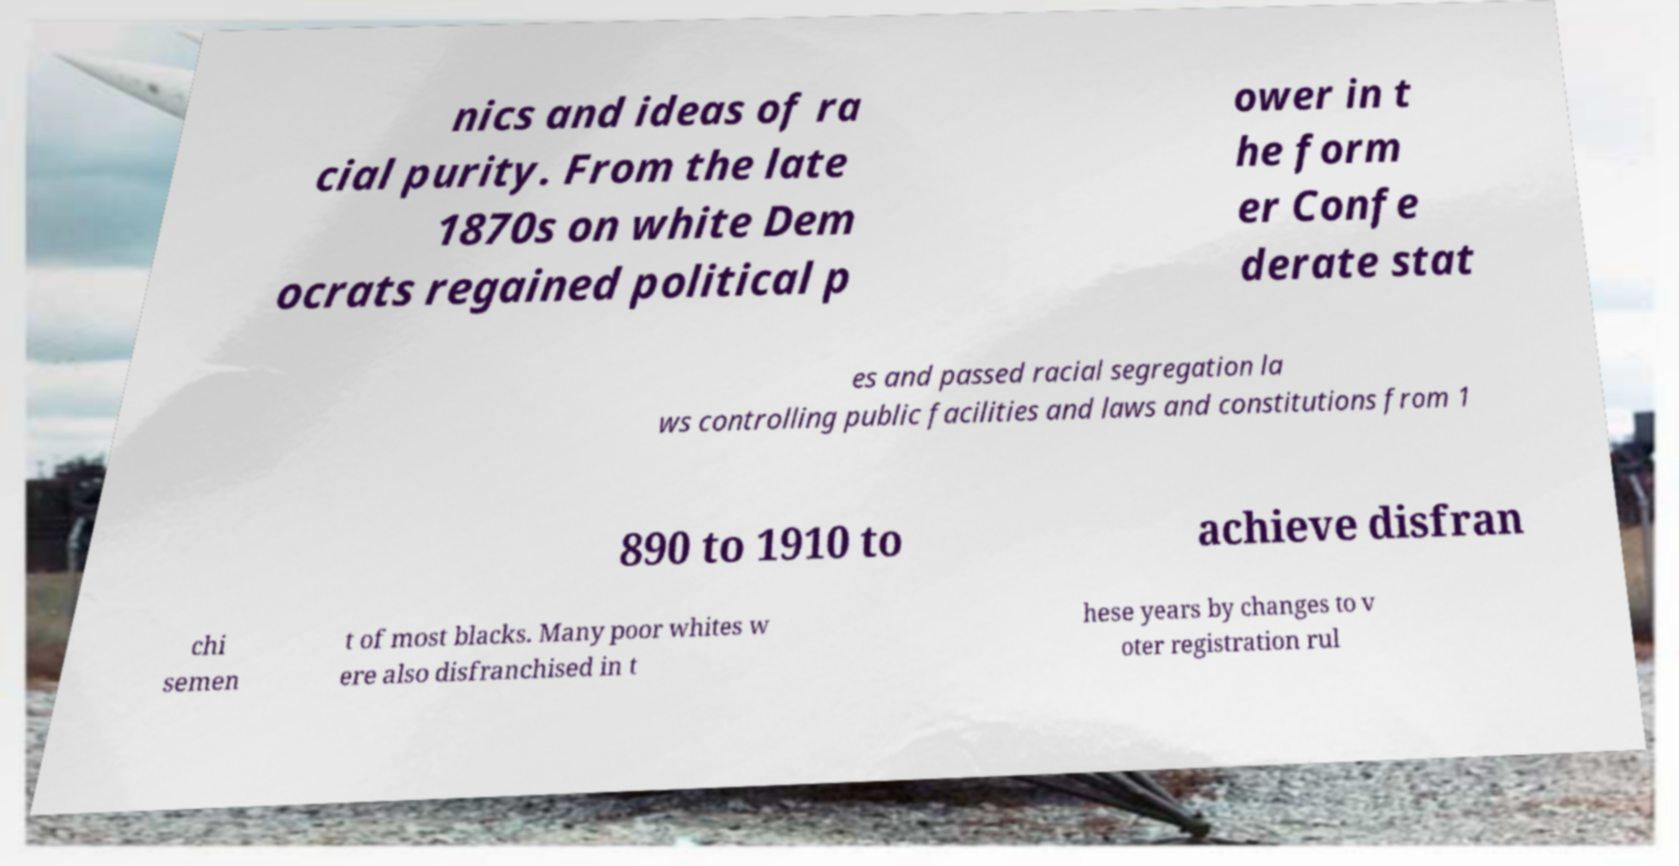What messages or text are displayed in this image? I need them in a readable, typed format. nics and ideas of ra cial purity. From the late 1870s on white Dem ocrats regained political p ower in t he form er Confe derate stat es and passed racial segregation la ws controlling public facilities and laws and constitutions from 1 890 to 1910 to achieve disfran chi semen t of most blacks. Many poor whites w ere also disfranchised in t hese years by changes to v oter registration rul 